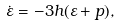<formula> <loc_0><loc_0><loc_500><loc_500>\dot { \varepsilon } = - 3 h ( \varepsilon + p ) ,</formula> 